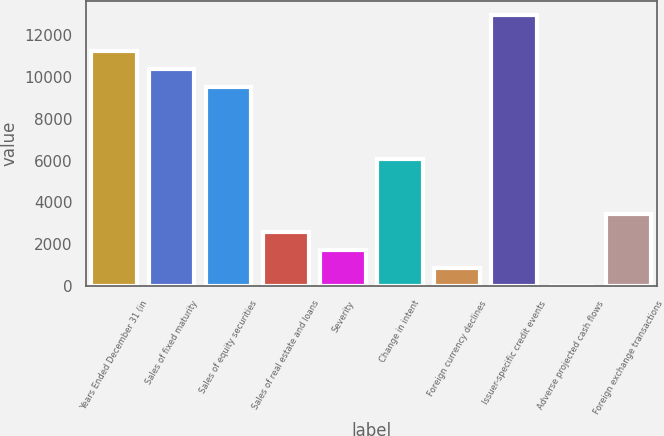Convert chart. <chart><loc_0><loc_0><loc_500><loc_500><bar_chart><fcel>Years Ended December 31 (in<fcel>Sales of fixed maturity<fcel>Sales of equity securities<fcel>Sales of real estate and loans<fcel>Severity<fcel>Change in intent<fcel>Foreign currency declines<fcel>Issuer-specific credit events<fcel>Adverse projected cash flows<fcel>Foreign exchange transactions<nl><fcel>11244.8<fcel>10380.2<fcel>9515.6<fcel>2598.8<fcel>1734.2<fcel>6057.2<fcel>869.6<fcel>12974<fcel>5<fcel>3463.4<nl></chart> 